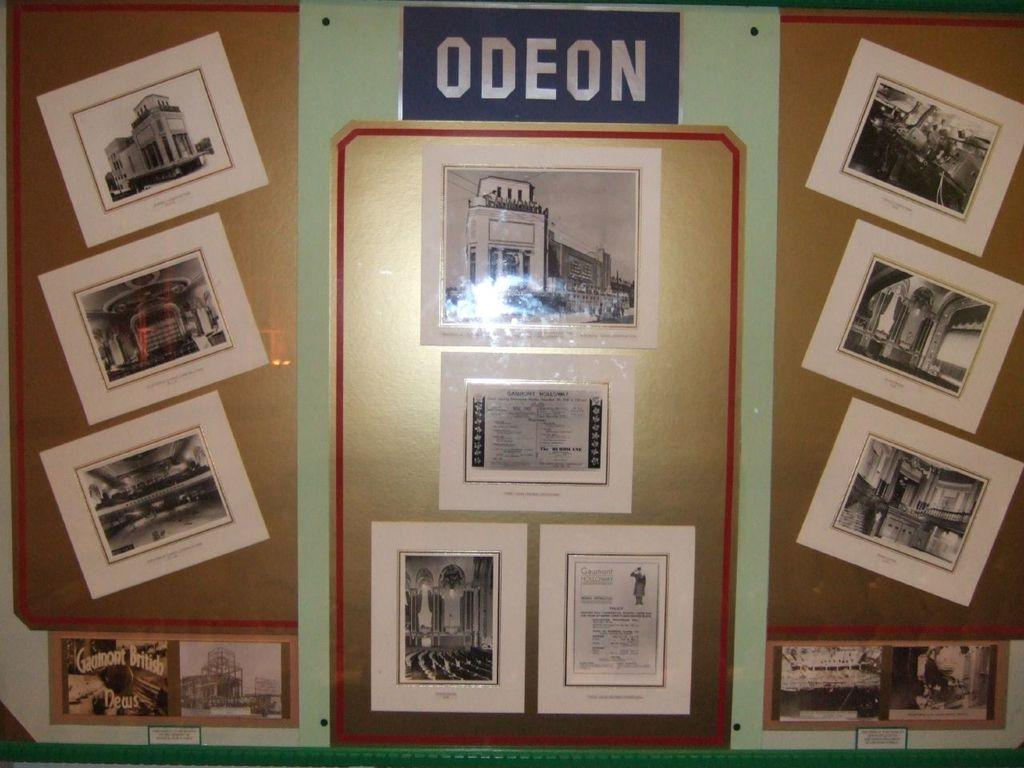What is the main object in the image? There is a board in the image. What is on the board? There are pictures pasted on the board, and there is writing on the board. What does the moon look like in the image? There is no moon present in the image. Who is the creator of the board in the image? The creator of the board is not mentioned in the image or the provided facts. 